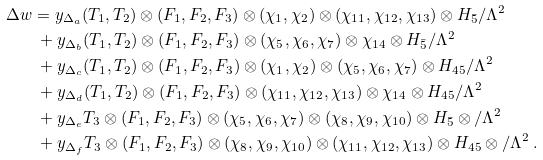Convert formula to latex. <formula><loc_0><loc_0><loc_500><loc_500>\Delta w & = y _ { \Delta _ { a } } ( T _ { 1 } , T _ { 2 } ) \otimes ( F _ { 1 } , F _ { 2 } , F _ { 3 } ) \otimes ( \chi _ { 1 } , \chi _ { 2 } ) \otimes ( \chi _ { 1 1 } , \chi _ { 1 2 } , \chi _ { 1 3 } ) \otimes H _ { \bar { 5 } } / \Lambda ^ { 2 } \\ & \ + y _ { \Delta _ { b } } ( T _ { 1 } , T _ { 2 } ) \otimes ( F _ { 1 } , F _ { 2 } , F _ { 3 } ) \otimes ( \chi _ { 5 } , \chi _ { 6 } , \chi _ { 7 } ) \otimes \chi _ { 1 4 } \otimes H _ { \bar { 5 } } / \Lambda ^ { 2 } \\ & \ + y _ { \Delta _ { c } } ( T _ { 1 } , T _ { 2 } ) \otimes ( F _ { 1 } , F _ { 2 } , F _ { 3 } ) \otimes ( \chi _ { 1 } , \chi _ { 2 } ) \otimes ( \chi _ { 5 } , \chi _ { 6 } , \chi _ { 7 } ) \otimes H _ { 4 5 } / \Lambda ^ { 2 } \\ & \ + y _ { \Delta _ { d } } ( T _ { 1 } , T _ { 2 } ) \otimes ( F _ { 1 } , F _ { 2 } , F _ { 3 } ) \otimes ( \chi _ { 1 1 } , \chi _ { 1 2 } , \chi _ { 1 3 } ) \otimes \chi _ { 1 4 } \otimes H _ { 4 5 } / \Lambda ^ { 2 } \\ & \ + y _ { \Delta _ { e } } T _ { 3 } \otimes ( F _ { 1 } , F _ { 2 } , F _ { 3 } ) \otimes ( \chi _ { 5 } , \chi _ { 6 } , \chi _ { 7 } ) \otimes ( \chi _ { 8 } , \chi _ { 9 } , \chi _ { 1 0 } ) \otimes H _ { \bar { 5 } } \otimes / \Lambda ^ { 2 } \\ & \ + y _ { \Delta _ { f } } T _ { 3 } \otimes ( F _ { 1 } , F _ { 2 } , F _ { 3 } ) \otimes ( \chi _ { 8 } , \chi _ { 9 } , \chi _ { 1 0 } ) \otimes ( \chi _ { 1 1 } , \chi _ { 1 2 } , \chi _ { 1 3 } ) \otimes H _ { 4 5 } \otimes / \Lambda ^ { 2 } \ .</formula> 